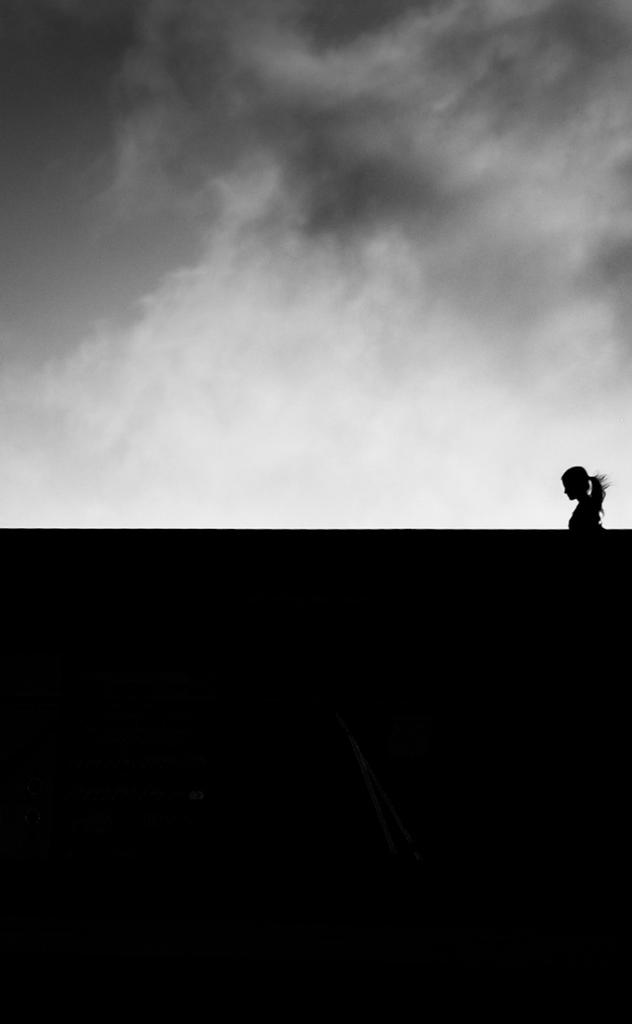Who or what is on the right side of the image? There is a person on the right side of the image. What is at the bottom of the image? There is a wall at the bottom of the image. What can be seen in the background of the image? The sky is visible in the background of the image. Where is the throne located in the image? There is no throne present in the image. What type of table is visible in the image? There is no table present in the image. 